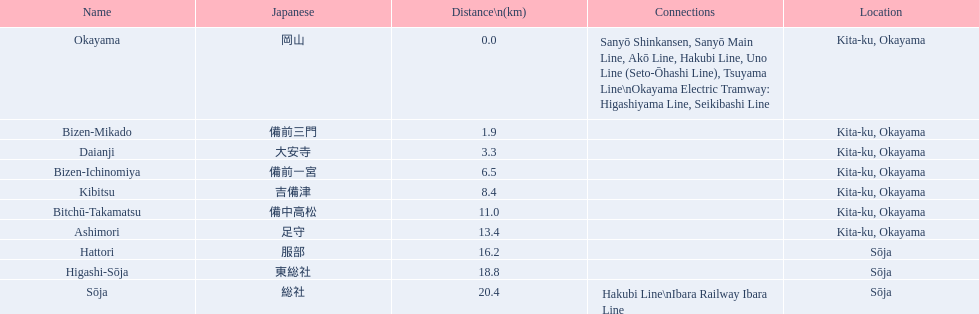What are the members of the kibi line? Okayama, Bizen-Mikado, Daianji, Bizen-Ichinomiya, Kibitsu, Bitchū-Takamatsu, Ashimori, Hattori, Higashi-Sōja, Sōja. Which of them have a distance of more than 1 km? Bizen-Mikado, Daianji, Bizen-Ichinomiya, Kibitsu, Bitchū-Takamatsu, Ashimori, Hattori, Higashi-Sōja, Sōja. Which of them have a distance of less than 2 km? Okayama, Bizen-Mikado. Which has a distance between 1 km and 2 km? Bizen-Mikado. 